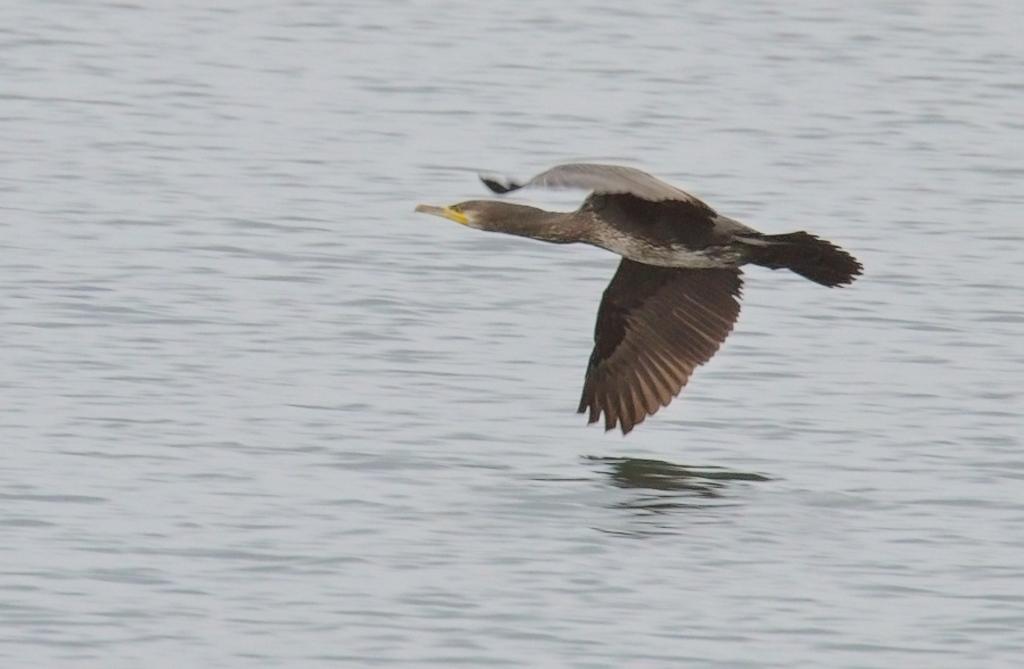Can you describe this image briefly? In this image there is a bird flying, and at the bottom there is a river. 